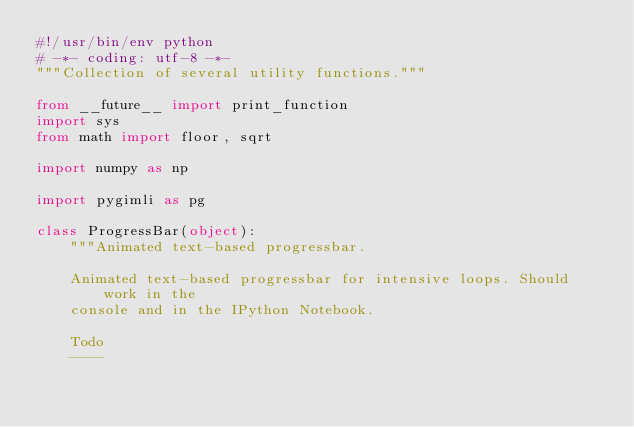<code> <loc_0><loc_0><loc_500><loc_500><_Python_>#!/usr/bin/env python
# -*- coding: utf-8 -*-
"""Collection of several utility functions."""

from __future__ import print_function
import sys
from math import floor, sqrt

import numpy as np

import pygimli as pg

class ProgressBar(object):
    """Animated text-based progressbar.

    Animated text-based progressbar for intensive loops. Should work in the
    console and in the IPython Notebook.

    Todo
    ----</code> 